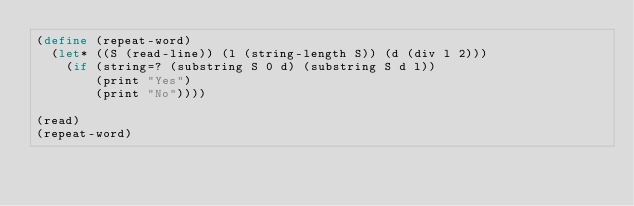Convert code to text. <code><loc_0><loc_0><loc_500><loc_500><_Scheme_>(define (repeat-word)
  (let* ((S (read-line)) (l (string-length S)) (d (div l 2)))
    (if (string=? (substring S 0 d) (substring S d l))
        (print "Yes")
        (print "No"))))

(read)
(repeat-word)</code> 